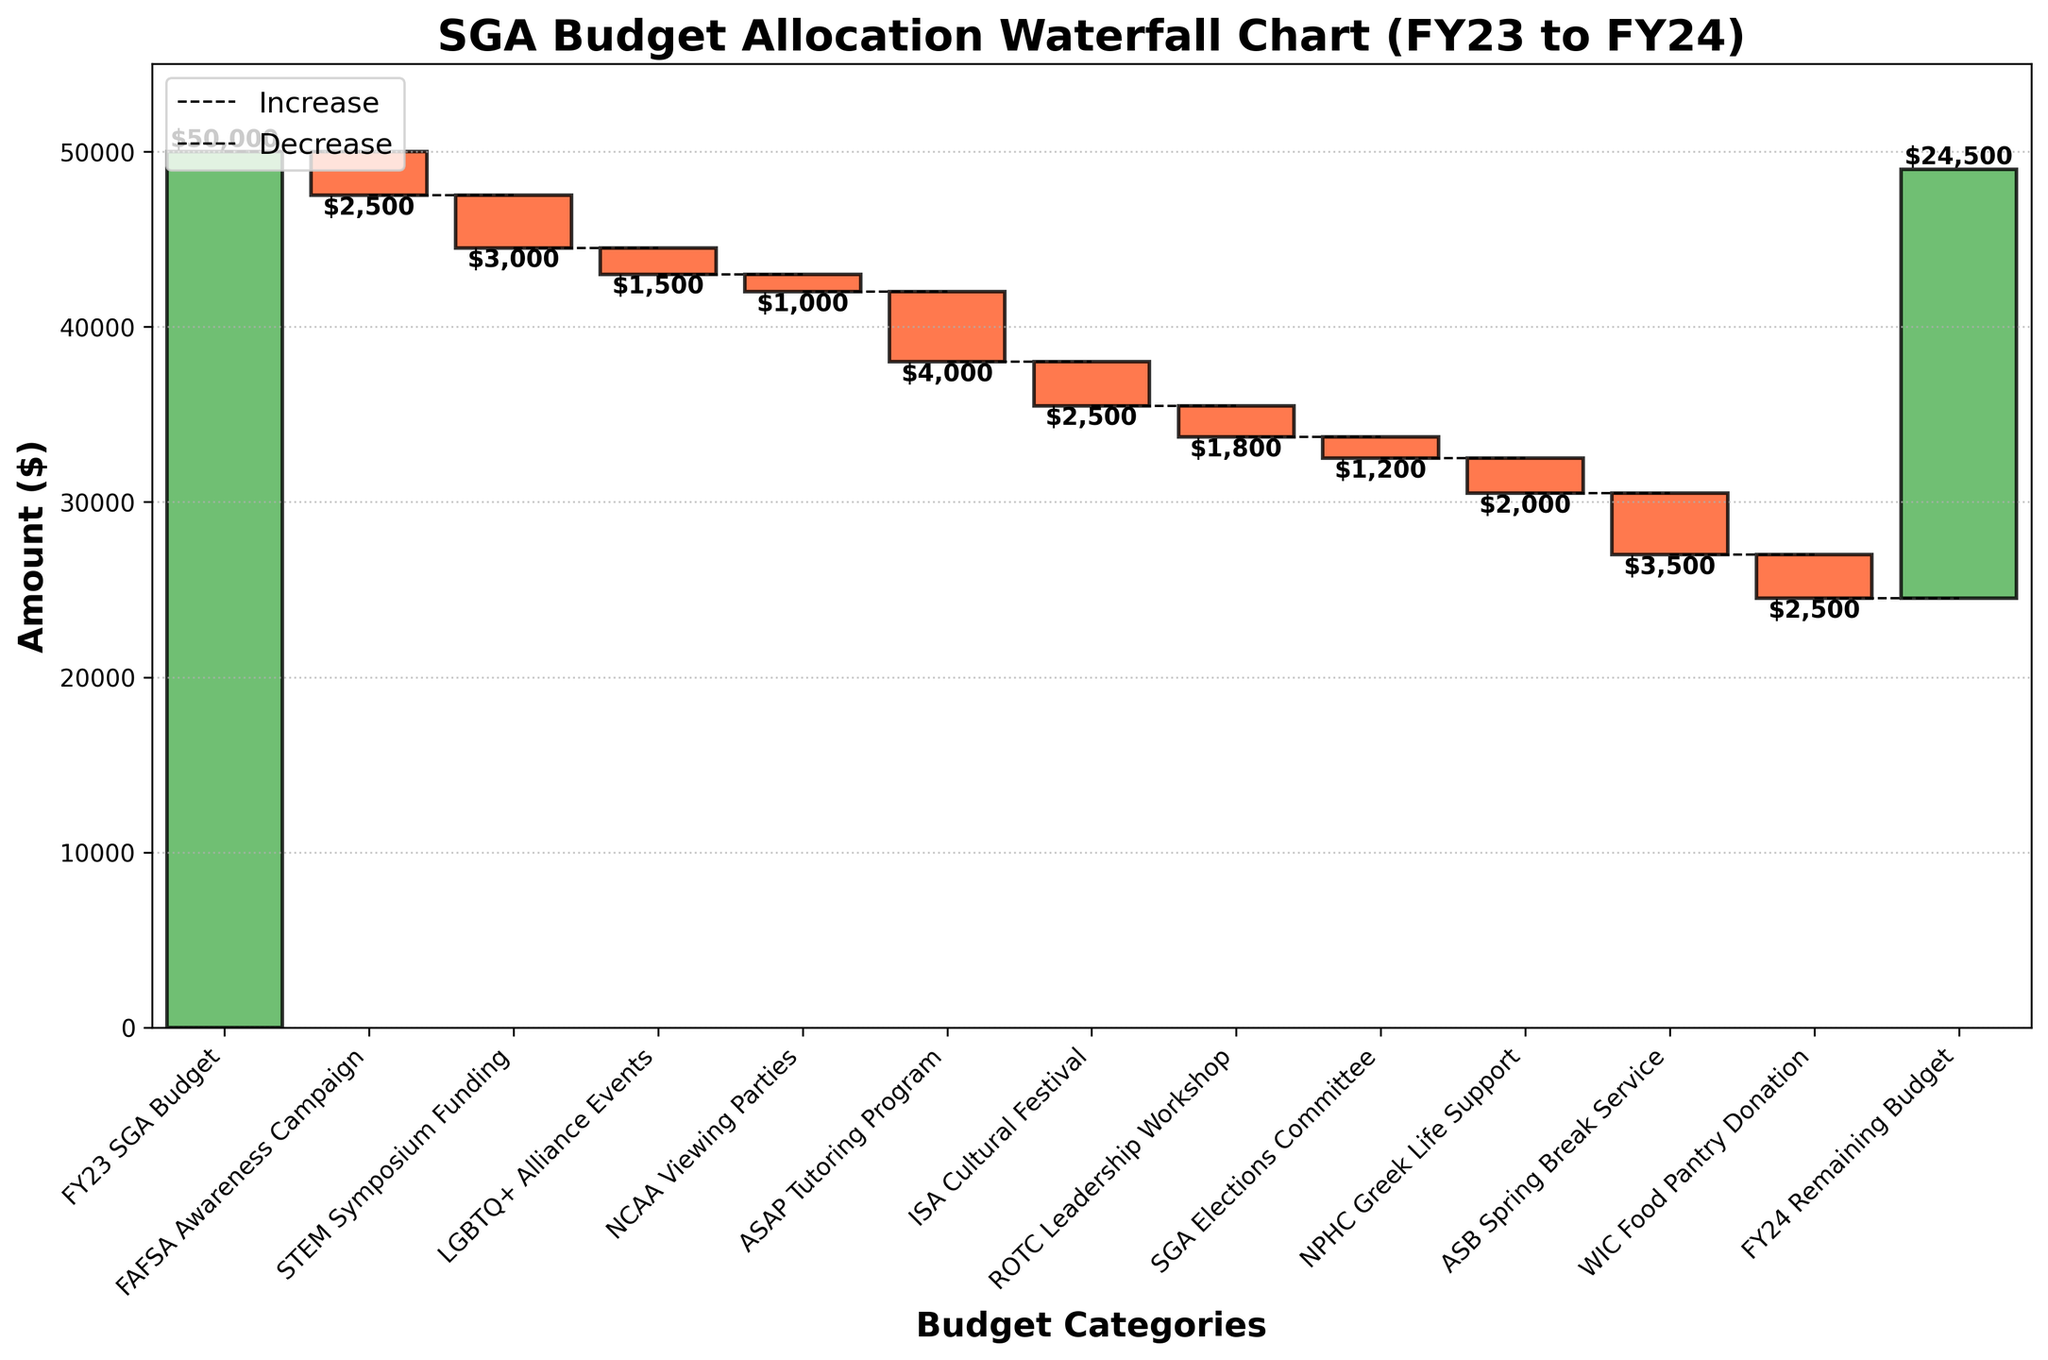What is the title of the chart? The title is usually placed at the top of the chart, indicating the main focus. In this chart, it's clearly displayed.
Answer: SGA Budget Allocation Waterfall Chart (FY23 to FY24) How much is the starting budget in FY23? Look for the first category label and its corresponding value. In this chart, it's labeled on the left side.
Answer: $50,000 Which category had the largest expenditure? Identify the category with the largest negative value, which can be seen in terms of the size and color of the bars.
Answer: STEM Symposium Funding What is the final remaining budget for FY24? Look for the last category label and its corresponding value, typically at the end of the chart.
Answer: $24,500 What is the total expenditure on all events? Sum up all the negative values from the categories to get the total expenditure. Categories with expenses are in red.
Answer: $25,500 How much was spent on LGBTQ+ Alliance Events compared to ROTC Leadership Workshop? Compare the negative values of these two categories. Identify the bars for each category to see the difference.
Answer: $1,500 vs. $1,800 How does the cumulative amount change after the FAFSA Awareness Campaign? Look at the cumulative sum after the FAFSA Awareness Campaign bar, starting from the initial budget and deducting the campaign expenditure.
Answer: $47,500 What is the effect of the NCAA Viewing Parties on the total budget? Identify the change in the cumulative amount before and after the NCAA Viewing Parties, considering its expenditure.
Answer: -$1,000 Which category had a smaller impact, SGA Elections Committee or ASAP Tutoring Program? Compare the bars of these categories based on their negative amounts to see which has a smaller expenditure.
Answer: SGA Elections Committee What percentage of the original FY23 SGA Budget remains in FY24? Calculate the remaining budget in FY24 as a percentage of the initial FY23 budget using the formula (FY24 Remaining Budget / FY23 SGA Budget) * 100.
Answer: 49% 